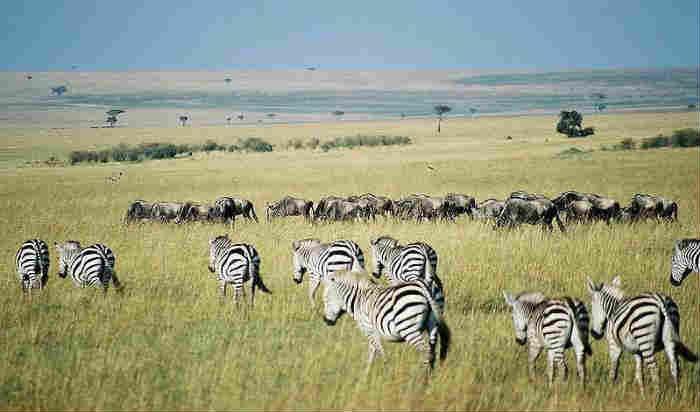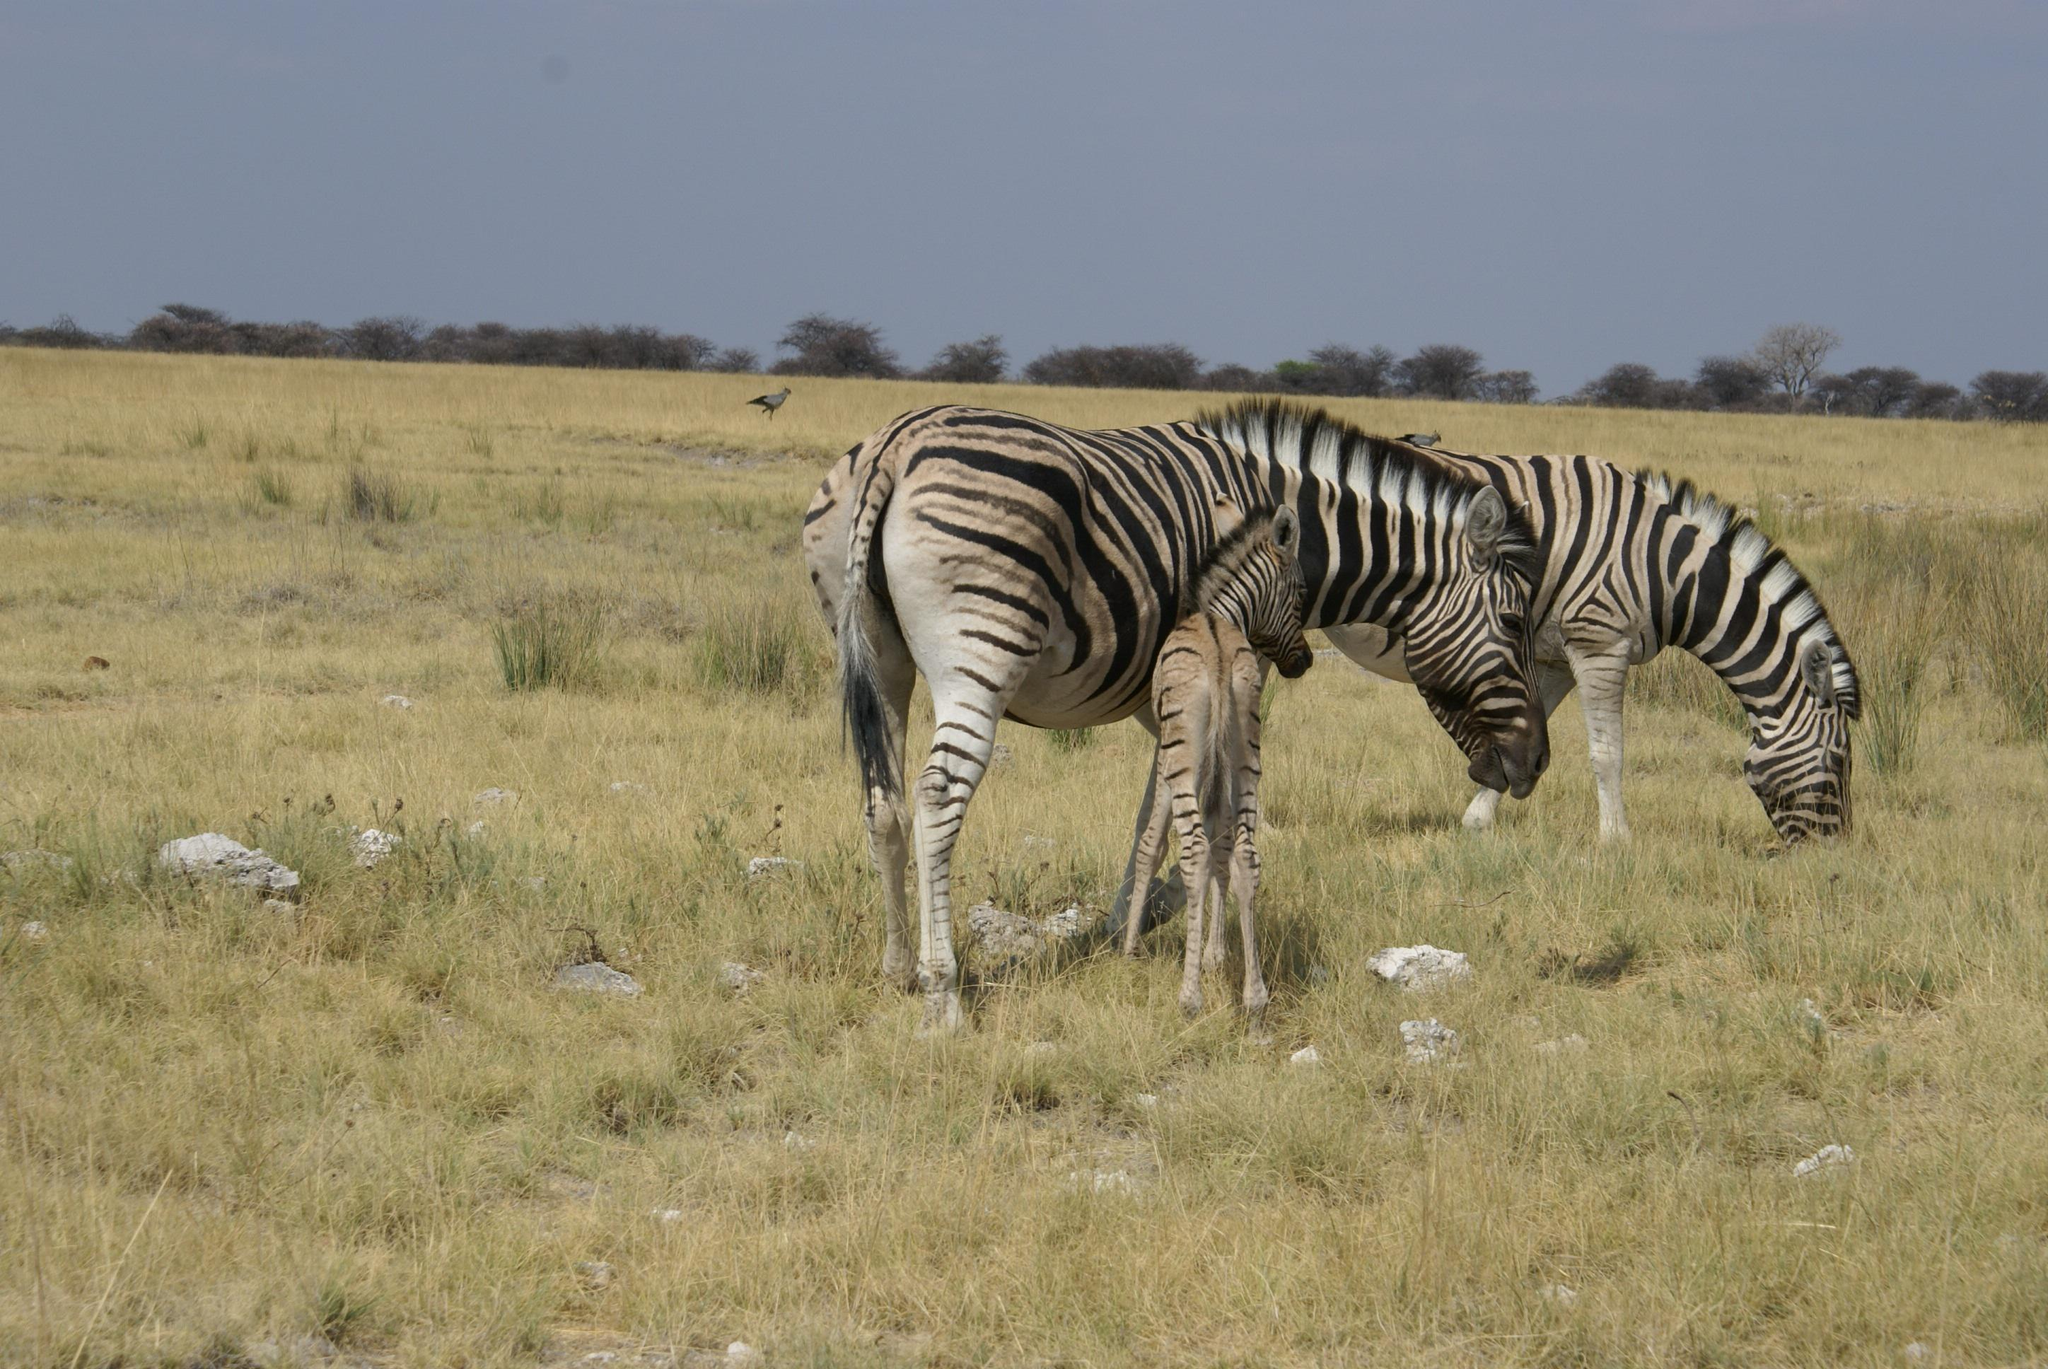The first image is the image on the left, the second image is the image on the right. Evaluate the accuracy of this statement regarding the images: "The left image contains at least three times as many zebras as the right image.". Is it true? Answer yes or no. Yes. 